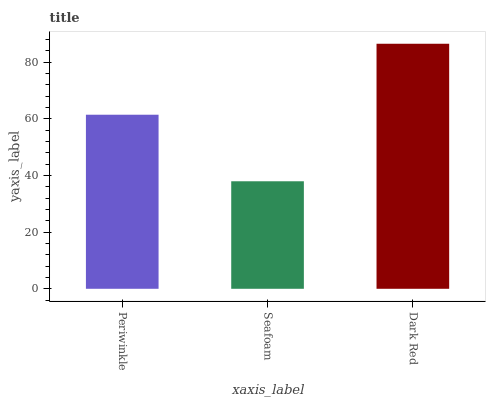Is Seafoam the minimum?
Answer yes or no. Yes. Is Dark Red the maximum?
Answer yes or no. Yes. Is Dark Red the minimum?
Answer yes or no. No. Is Seafoam the maximum?
Answer yes or no. No. Is Dark Red greater than Seafoam?
Answer yes or no. Yes. Is Seafoam less than Dark Red?
Answer yes or no. Yes. Is Seafoam greater than Dark Red?
Answer yes or no. No. Is Dark Red less than Seafoam?
Answer yes or no. No. Is Periwinkle the high median?
Answer yes or no. Yes. Is Periwinkle the low median?
Answer yes or no. Yes. Is Dark Red the high median?
Answer yes or no. No. Is Seafoam the low median?
Answer yes or no. No. 